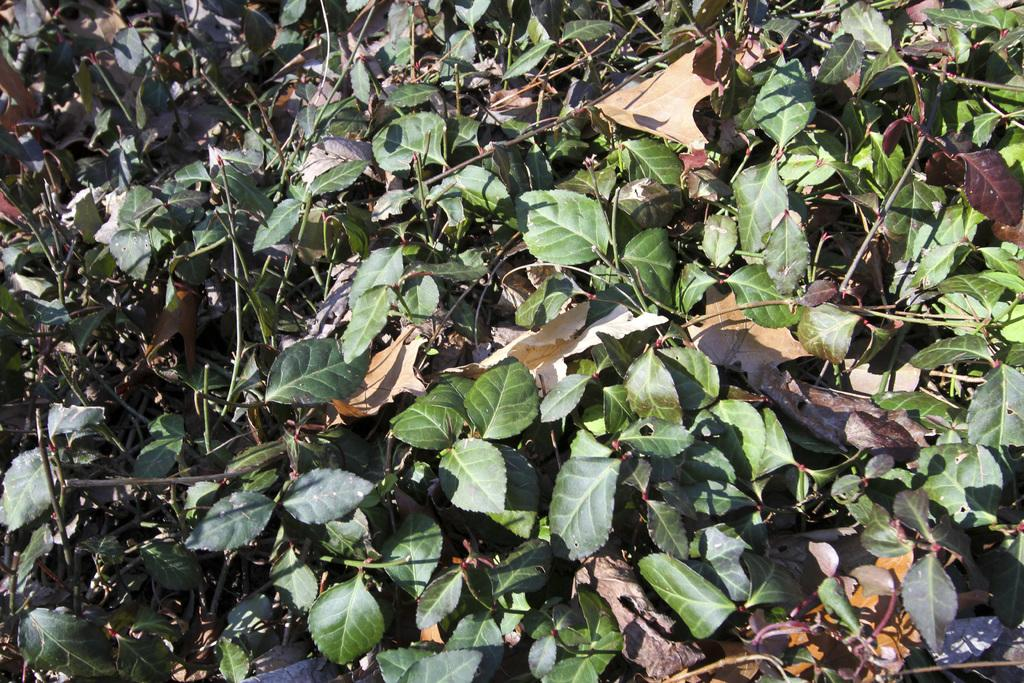What type of vegetation can be seen in the image? There are leaves in the image. What type of bait is being used to catch fish in the image? There is no mention of fish or bait in the image; it only contains leaves. 